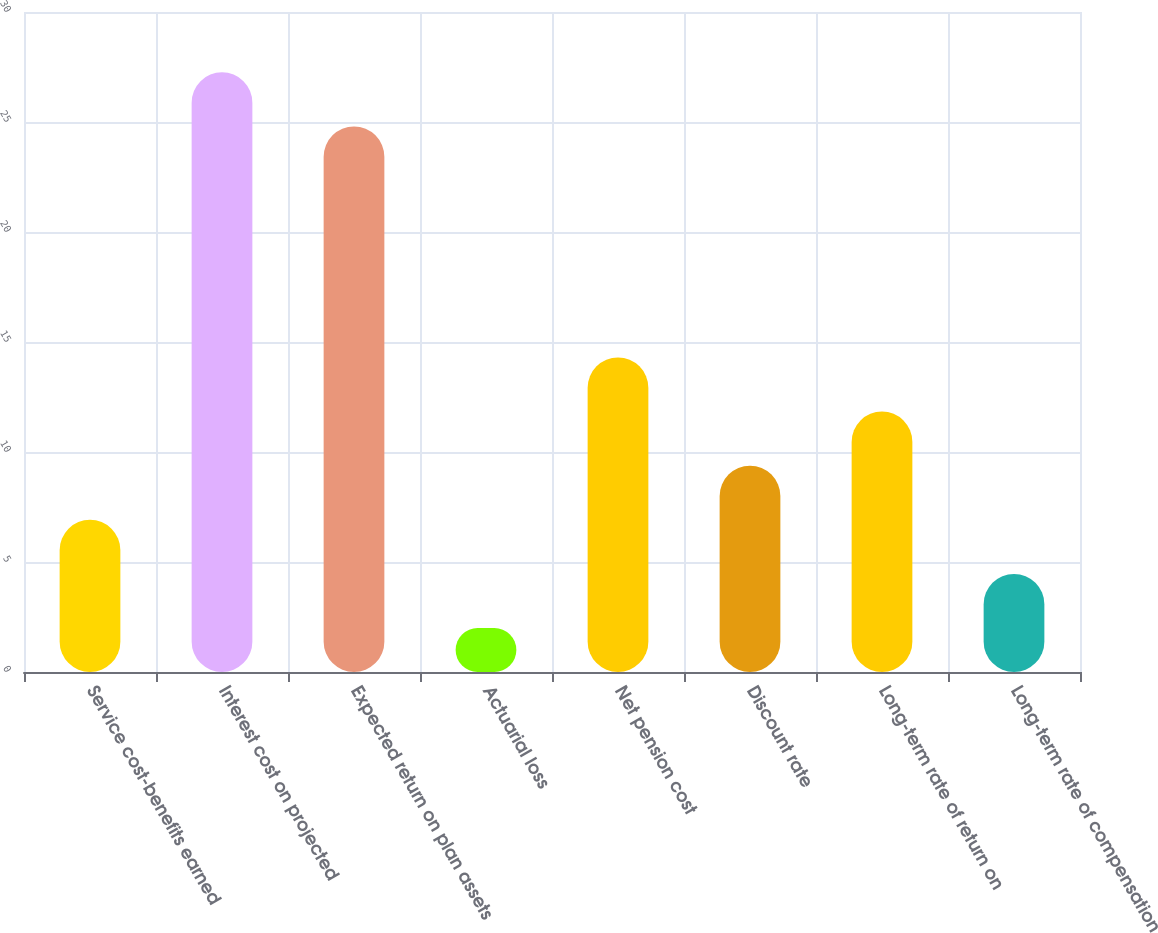Convert chart. <chart><loc_0><loc_0><loc_500><loc_500><bar_chart><fcel>Service cost-benefits earned<fcel>Interest cost on projected<fcel>Expected return on plan assets<fcel>Actuarial loss<fcel>Net pension cost<fcel>Discount rate<fcel>Long-term rate of return on<fcel>Long-term rate of compensation<nl><fcel>6.92<fcel>27.26<fcel>24.8<fcel>2<fcel>14.3<fcel>9.38<fcel>11.84<fcel>4.46<nl></chart> 